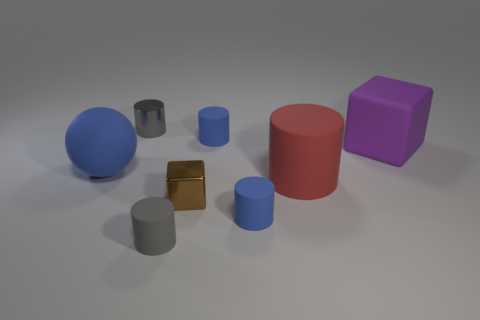The blue sphere is what size?
Your answer should be compact. Large. Are there more large red rubber cylinders that are left of the big cylinder than big purple matte blocks?
Give a very brief answer. No. How many large rubber cylinders are in front of the red rubber thing?
Your response must be concise. 0. Are there any blocks of the same size as the gray shiny cylinder?
Your response must be concise. Yes. There is another big object that is the same shape as the brown thing; what color is it?
Ensure brevity in your answer.  Purple. There is a gray object behind the metal cube; is its size the same as the gray cylinder in front of the blue sphere?
Your answer should be very brief. Yes. Are there any other big matte things that have the same shape as the big purple object?
Ensure brevity in your answer.  No. Are there an equal number of small blue things that are behind the gray metal cylinder and tiny yellow rubber spheres?
Offer a terse response. Yes. Do the gray metallic cylinder and the rubber sphere that is behind the small metal block have the same size?
Offer a terse response. No. What number of big red cylinders have the same material as the large sphere?
Provide a succinct answer. 1. 